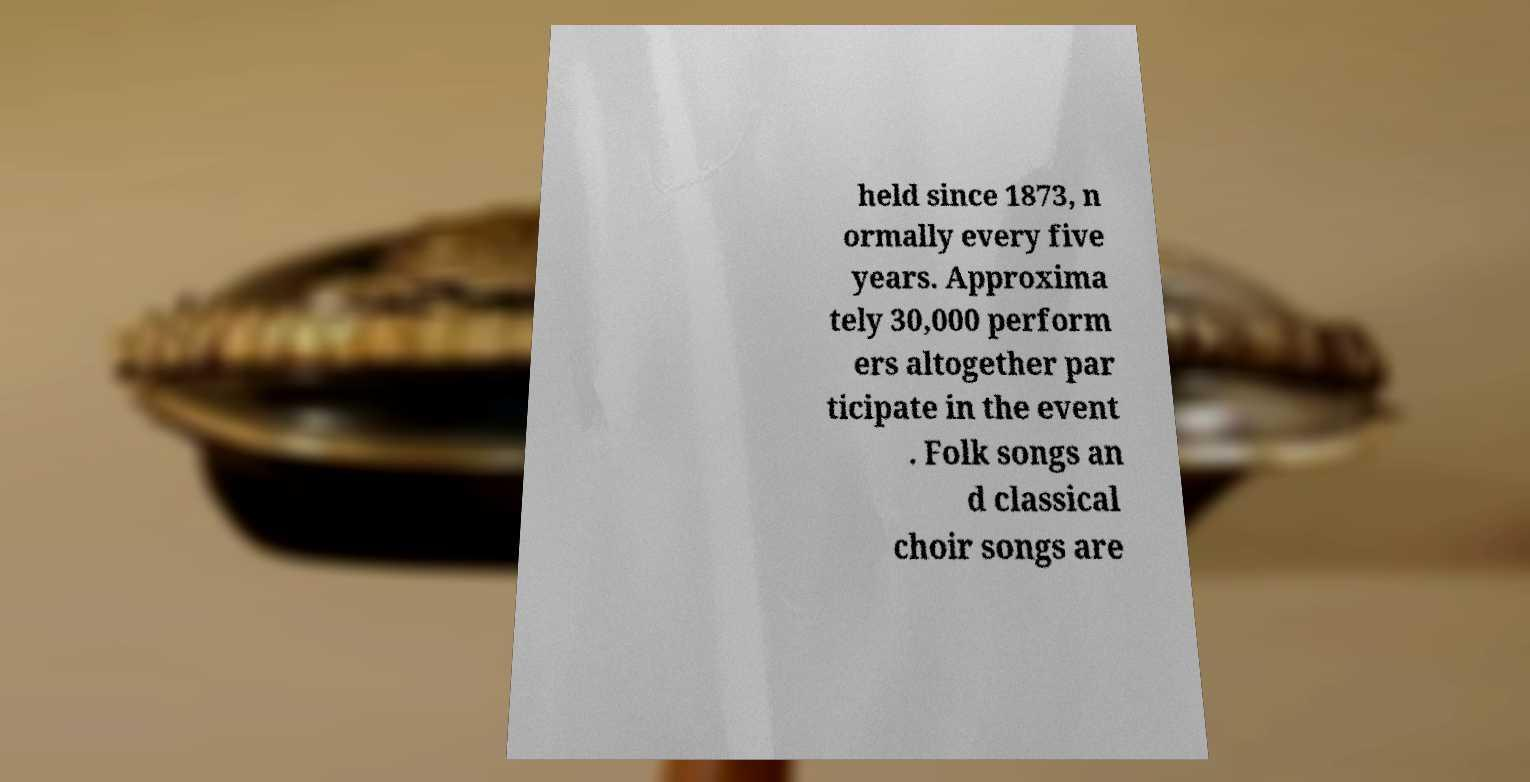Could you extract and type out the text from this image? held since 1873, n ormally every five years. Approxima tely 30,000 perform ers altogether par ticipate in the event . Folk songs an d classical choir songs are 